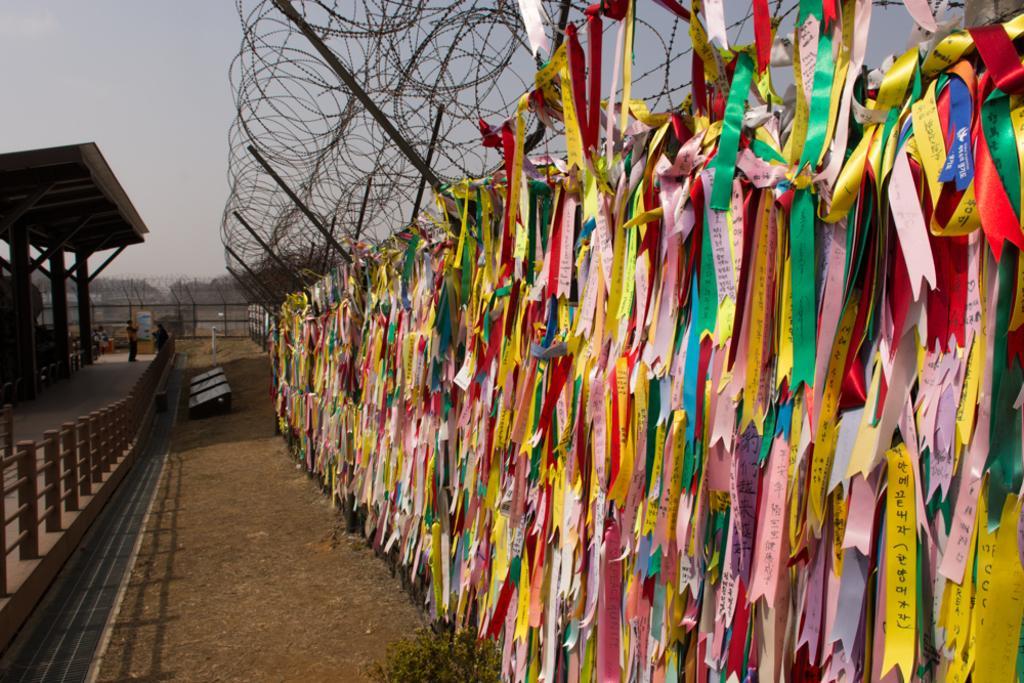In one or two sentences, can you explain what this image depicts? In this image I can see multi color ribbons hanged to the railing. Background I can see a shed, dried trees and sky in gray color. 